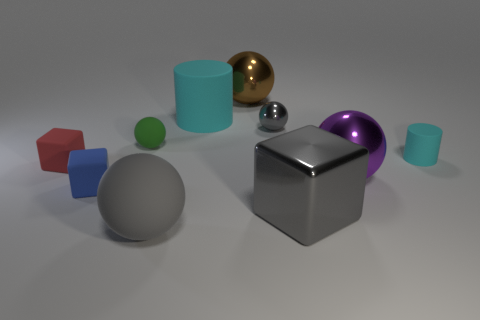Is there a thing that has the same color as the small cylinder?
Your answer should be very brief. Yes. Are the big brown ball and the small sphere that is behind the tiny green matte sphere made of the same material?
Keep it short and to the point. Yes. What number of tiny objects are either objects or purple things?
Give a very brief answer. 5. There is a tiny thing that is the same color as the large shiny block; what material is it?
Offer a very short reply. Metal. Is the number of large cyan matte cylinders less than the number of matte cylinders?
Your response must be concise. Yes. Does the gray shiny thing behind the small red matte object have the same size as the rubber cylinder on the left side of the big purple metal object?
Ensure brevity in your answer.  No. What number of cyan things are either small cylinders or small metal things?
Provide a short and direct response. 1. What size is the matte ball that is the same color as the big block?
Ensure brevity in your answer.  Large. Are there more blue objects than big spheres?
Offer a terse response. No. Do the large cube and the tiny shiny object have the same color?
Your answer should be very brief. Yes. 